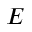<formula> <loc_0><loc_0><loc_500><loc_500>E</formula> 